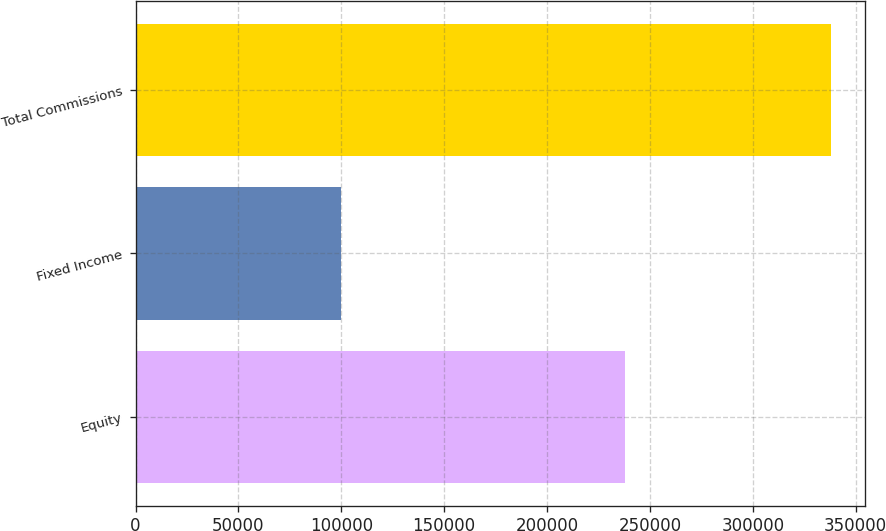<chart> <loc_0><loc_0><loc_500><loc_500><bar_chart><fcel>Equity<fcel>Fixed Income<fcel>Total Commissions<nl><fcel>237920<fcel>99870<fcel>337790<nl></chart> 